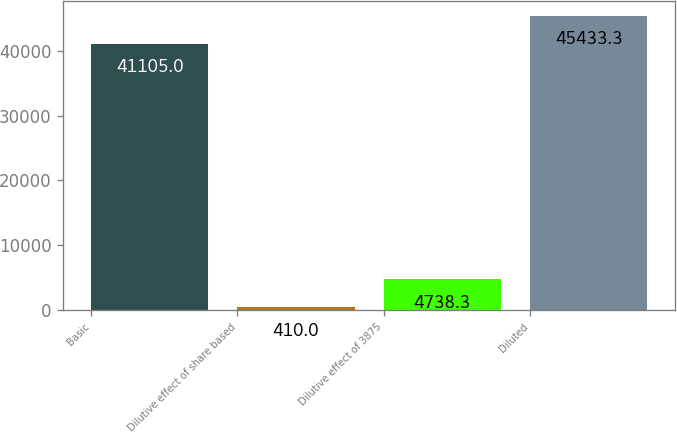Convert chart. <chart><loc_0><loc_0><loc_500><loc_500><bar_chart><fcel>Basic<fcel>Dilutive effect of share based<fcel>Dilutive effect of 3875<fcel>Diluted<nl><fcel>41105<fcel>410<fcel>4738.3<fcel>45433.3<nl></chart> 